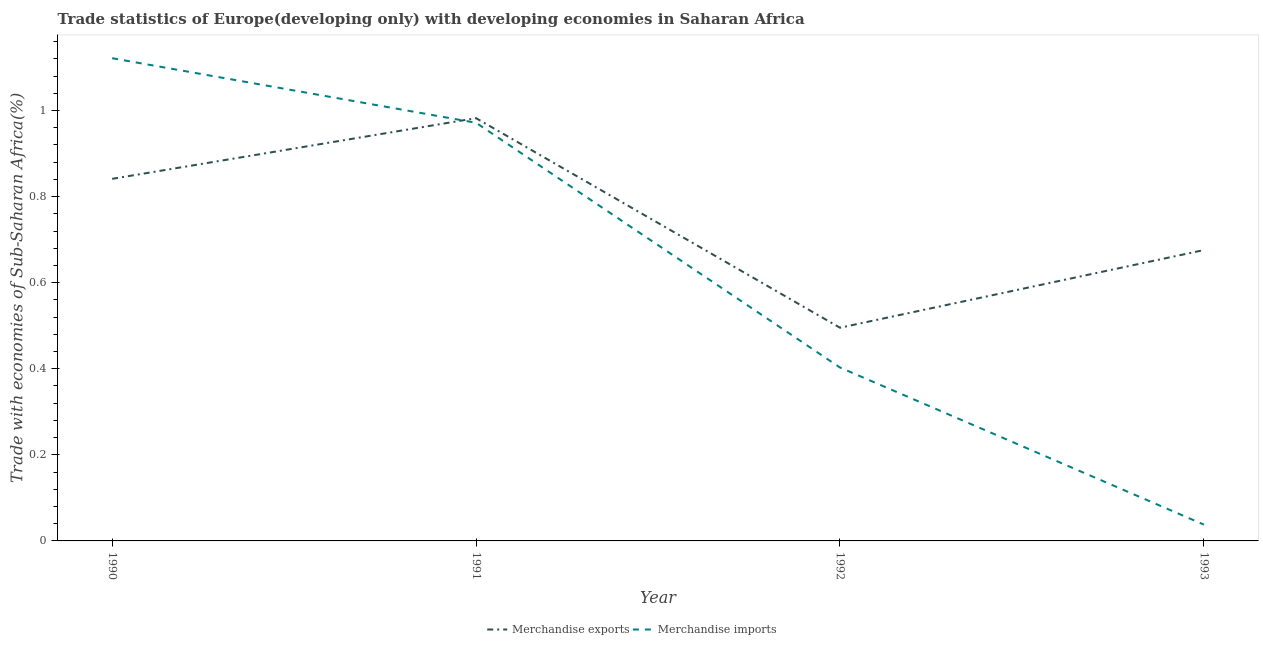What is the merchandise imports in 1991?
Your answer should be very brief. 0.97. Across all years, what is the maximum merchandise exports?
Offer a very short reply. 0.98. Across all years, what is the minimum merchandise imports?
Offer a very short reply. 0.04. In which year was the merchandise exports minimum?
Keep it short and to the point. 1992. What is the total merchandise exports in the graph?
Your response must be concise. 2.99. What is the difference between the merchandise imports in 1990 and that in 1993?
Keep it short and to the point. 1.08. What is the difference between the merchandise imports in 1991 and the merchandise exports in 1990?
Offer a very short reply. 0.13. What is the average merchandise imports per year?
Your response must be concise. 0.63. In the year 1993, what is the difference between the merchandise exports and merchandise imports?
Offer a terse response. 0.64. What is the ratio of the merchandise exports in 1991 to that in 1993?
Offer a very short reply. 1.45. Is the merchandise imports in 1990 less than that in 1991?
Keep it short and to the point. No. What is the difference between the highest and the second highest merchandise exports?
Keep it short and to the point. 0.14. What is the difference between the highest and the lowest merchandise exports?
Provide a short and direct response. 0.49. In how many years, is the merchandise exports greater than the average merchandise exports taken over all years?
Your response must be concise. 2. What is the difference between two consecutive major ticks on the Y-axis?
Your answer should be compact. 0.2. What is the title of the graph?
Offer a terse response. Trade statistics of Europe(developing only) with developing economies in Saharan Africa. Does "Age 15+" appear as one of the legend labels in the graph?
Make the answer very short. No. What is the label or title of the X-axis?
Your response must be concise. Year. What is the label or title of the Y-axis?
Offer a very short reply. Trade with economies of Sub-Saharan Africa(%). What is the Trade with economies of Sub-Saharan Africa(%) of Merchandise exports in 1990?
Your answer should be very brief. 0.84. What is the Trade with economies of Sub-Saharan Africa(%) in Merchandise imports in 1990?
Offer a very short reply. 1.12. What is the Trade with economies of Sub-Saharan Africa(%) in Merchandise exports in 1991?
Provide a short and direct response. 0.98. What is the Trade with economies of Sub-Saharan Africa(%) of Merchandise imports in 1991?
Give a very brief answer. 0.97. What is the Trade with economies of Sub-Saharan Africa(%) of Merchandise exports in 1992?
Offer a terse response. 0.5. What is the Trade with economies of Sub-Saharan Africa(%) in Merchandise imports in 1992?
Your response must be concise. 0.4. What is the Trade with economies of Sub-Saharan Africa(%) of Merchandise exports in 1993?
Keep it short and to the point. 0.68. What is the Trade with economies of Sub-Saharan Africa(%) in Merchandise imports in 1993?
Offer a very short reply. 0.04. Across all years, what is the maximum Trade with economies of Sub-Saharan Africa(%) of Merchandise exports?
Provide a short and direct response. 0.98. Across all years, what is the maximum Trade with economies of Sub-Saharan Africa(%) of Merchandise imports?
Your answer should be compact. 1.12. Across all years, what is the minimum Trade with economies of Sub-Saharan Africa(%) in Merchandise exports?
Ensure brevity in your answer.  0.5. Across all years, what is the minimum Trade with economies of Sub-Saharan Africa(%) in Merchandise imports?
Provide a succinct answer. 0.04. What is the total Trade with economies of Sub-Saharan Africa(%) in Merchandise exports in the graph?
Give a very brief answer. 2.99. What is the total Trade with economies of Sub-Saharan Africa(%) in Merchandise imports in the graph?
Provide a succinct answer. 2.53. What is the difference between the Trade with economies of Sub-Saharan Africa(%) in Merchandise exports in 1990 and that in 1991?
Give a very brief answer. -0.14. What is the difference between the Trade with economies of Sub-Saharan Africa(%) in Merchandise exports in 1990 and that in 1992?
Your response must be concise. 0.35. What is the difference between the Trade with economies of Sub-Saharan Africa(%) of Merchandise imports in 1990 and that in 1992?
Keep it short and to the point. 0.72. What is the difference between the Trade with economies of Sub-Saharan Africa(%) of Merchandise exports in 1990 and that in 1993?
Give a very brief answer. 0.17. What is the difference between the Trade with economies of Sub-Saharan Africa(%) in Merchandise imports in 1990 and that in 1993?
Offer a terse response. 1.08. What is the difference between the Trade with economies of Sub-Saharan Africa(%) in Merchandise exports in 1991 and that in 1992?
Keep it short and to the point. 0.49. What is the difference between the Trade with economies of Sub-Saharan Africa(%) of Merchandise imports in 1991 and that in 1992?
Your answer should be compact. 0.57. What is the difference between the Trade with economies of Sub-Saharan Africa(%) of Merchandise exports in 1991 and that in 1993?
Offer a terse response. 0.31. What is the difference between the Trade with economies of Sub-Saharan Africa(%) of Merchandise imports in 1991 and that in 1993?
Give a very brief answer. 0.93. What is the difference between the Trade with economies of Sub-Saharan Africa(%) in Merchandise exports in 1992 and that in 1993?
Provide a short and direct response. -0.18. What is the difference between the Trade with economies of Sub-Saharan Africa(%) in Merchandise imports in 1992 and that in 1993?
Keep it short and to the point. 0.36. What is the difference between the Trade with economies of Sub-Saharan Africa(%) in Merchandise exports in 1990 and the Trade with economies of Sub-Saharan Africa(%) in Merchandise imports in 1991?
Make the answer very short. -0.13. What is the difference between the Trade with economies of Sub-Saharan Africa(%) in Merchandise exports in 1990 and the Trade with economies of Sub-Saharan Africa(%) in Merchandise imports in 1992?
Give a very brief answer. 0.44. What is the difference between the Trade with economies of Sub-Saharan Africa(%) of Merchandise exports in 1990 and the Trade with economies of Sub-Saharan Africa(%) of Merchandise imports in 1993?
Give a very brief answer. 0.8. What is the difference between the Trade with economies of Sub-Saharan Africa(%) of Merchandise exports in 1991 and the Trade with economies of Sub-Saharan Africa(%) of Merchandise imports in 1992?
Make the answer very short. 0.58. What is the difference between the Trade with economies of Sub-Saharan Africa(%) in Merchandise exports in 1992 and the Trade with economies of Sub-Saharan Africa(%) in Merchandise imports in 1993?
Offer a very short reply. 0.46. What is the average Trade with economies of Sub-Saharan Africa(%) of Merchandise exports per year?
Make the answer very short. 0.75. What is the average Trade with economies of Sub-Saharan Africa(%) in Merchandise imports per year?
Keep it short and to the point. 0.63. In the year 1990, what is the difference between the Trade with economies of Sub-Saharan Africa(%) in Merchandise exports and Trade with economies of Sub-Saharan Africa(%) in Merchandise imports?
Ensure brevity in your answer.  -0.28. In the year 1991, what is the difference between the Trade with economies of Sub-Saharan Africa(%) in Merchandise exports and Trade with economies of Sub-Saharan Africa(%) in Merchandise imports?
Make the answer very short. 0.01. In the year 1992, what is the difference between the Trade with economies of Sub-Saharan Africa(%) of Merchandise exports and Trade with economies of Sub-Saharan Africa(%) of Merchandise imports?
Offer a very short reply. 0.09. In the year 1993, what is the difference between the Trade with economies of Sub-Saharan Africa(%) of Merchandise exports and Trade with economies of Sub-Saharan Africa(%) of Merchandise imports?
Your answer should be very brief. 0.64. What is the ratio of the Trade with economies of Sub-Saharan Africa(%) of Merchandise exports in 1990 to that in 1991?
Ensure brevity in your answer.  0.86. What is the ratio of the Trade with economies of Sub-Saharan Africa(%) of Merchandise imports in 1990 to that in 1991?
Your response must be concise. 1.15. What is the ratio of the Trade with economies of Sub-Saharan Africa(%) of Merchandise exports in 1990 to that in 1992?
Your answer should be very brief. 1.7. What is the ratio of the Trade with economies of Sub-Saharan Africa(%) of Merchandise imports in 1990 to that in 1992?
Offer a very short reply. 2.78. What is the ratio of the Trade with economies of Sub-Saharan Africa(%) in Merchandise exports in 1990 to that in 1993?
Keep it short and to the point. 1.24. What is the ratio of the Trade with economies of Sub-Saharan Africa(%) of Merchandise imports in 1990 to that in 1993?
Provide a short and direct response. 29.63. What is the ratio of the Trade with economies of Sub-Saharan Africa(%) in Merchandise exports in 1991 to that in 1992?
Ensure brevity in your answer.  1.98. What is the ratio of the Trade with economies of Sub-Saharan Africa(%) of Merchandise imports in 1991 to that in 1992?
Make the answer very short. 2.41. What is the ratio of the Trade with economies of Sub-Saharan Africa(%) of Merchandise exports in 1991 to that in 1993?
Your response must be concise. 1.45. What is the ratio of the Trade with economies of Sub-Saharan Africa(%) of Merchandise imports in 1991 to that in 1993?
Keep it short and to the point. 25.66. What is the ratio of the Trade with economies of Sub-Saharan Africa(%) in Merchandise exports in 1992 to that in 1993?
Give a very brief answer. 0.73. What is the ratio of the Trade with economies of Sub-Saharan Africa(%) of Merchandise imports in 1992 to that in 1993?
Offer a very short reply. 10.64. What is the difference between the highest and the second highest Trade with economies of Sub-Saharan Africa(%) in Merchandise exports?
Provide a short and direct response. 0.14. What is the difference between the highest and the second highest Trade with economies of Sub-Saharan Africa(%) in Merchandise imports?
Keep it short and to the point. 0.15. What is the difference between the highest and the lowest Trade with economies of Sub-Saharan Africa(%) in Merchandise exports?
Give a very brief answer. 0.49. What is the difference between the highest and the lowest Trade with economies of Sub-Saharan Africa(%) in Merchandise imports?
Ensure brevity in your answer.  1.08. 